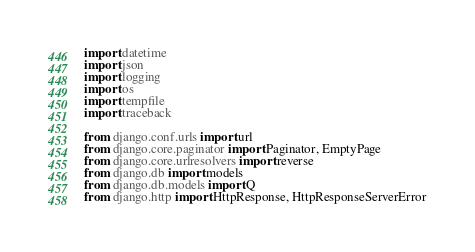Convert code to text. <code><loc_0><loc_0><loc_500><loc_500><_Python_>import datetime
import json
import logging
import os
import tempfile
import traceback

from django.conf.urls import url
from django.core.paginator import Paginator, EmptyPage
from django.core.urlresolvers import reverse
from django.db import models
from django.db.models import Q
from django.http import HttpResponse, HttpResponseServerError</code> 